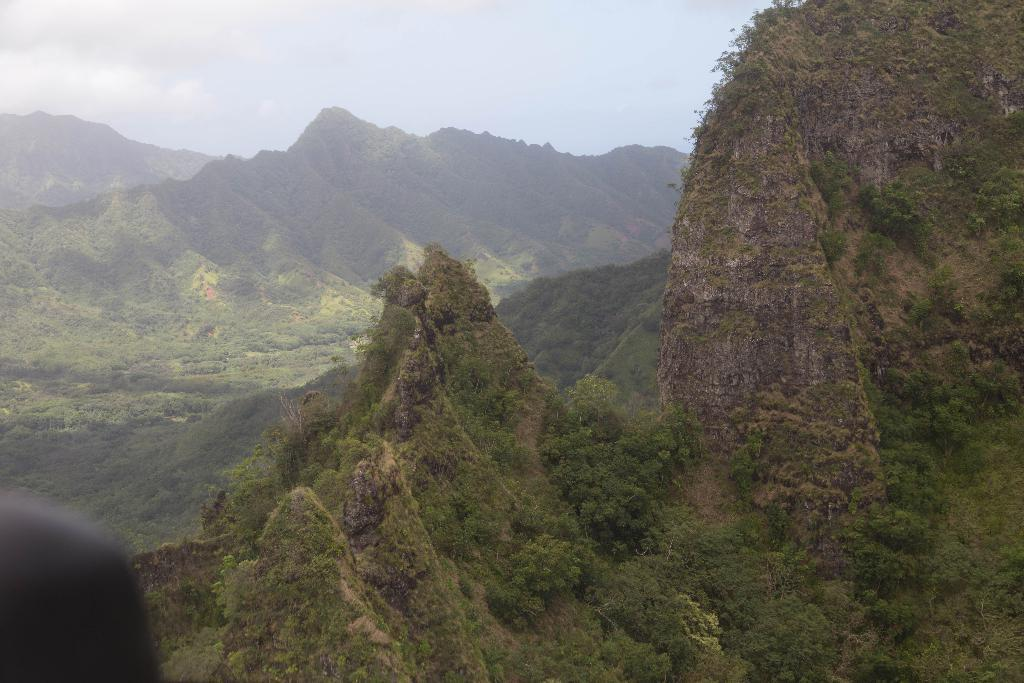What type of natural landscape is depicted in the image? The image features mountains and trees, indicating a natural landscape. What can be seen in the sky in the image? There are clouds in the sky in the image. What is visible in the background of the image? The sky is visible in the background of the image. Can you describe the black-colored object on the bottom left side of the image? There is a black-colored object on the bottom left side of the image, but its specific nature cannot be determined from the provided facts. What type of experience does the beetle have while walking on the ink in the image? There is no beetle or ink present in the image, so this question cannot be answered. 